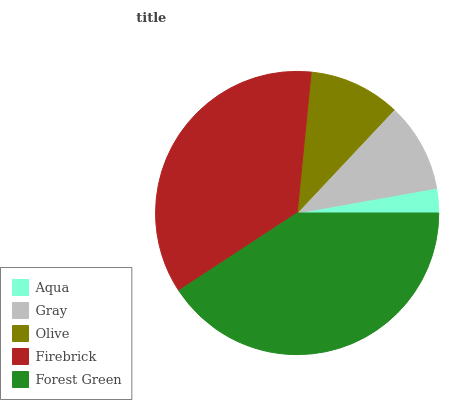Is Aqua the minimum?
Answer yes or no. Yes. Is Forest Green the maximum?
Answer yes or no. Yes. Is Gray the minimum?
Answer yes or no. No. Is Gray the maximum?
Answer yes or no. No. Is Gray greater than Aqua?
Answer yes or no. Yes. Is Aqua less than Gray?
Answer yes or no. Yes. Is Aqua greater than Gray?
Answer yes or no. No. Is Gray less than Aqua?
Answer yes or no. No. Is Olive the high median?
Answer yes or no. Yes. Is Olive the low median?
Answer yes or no. Yes. Is Forest Green the high median?
Answer yes or no. No. Is Firebrick the low median?
Answer yes or no. No. 